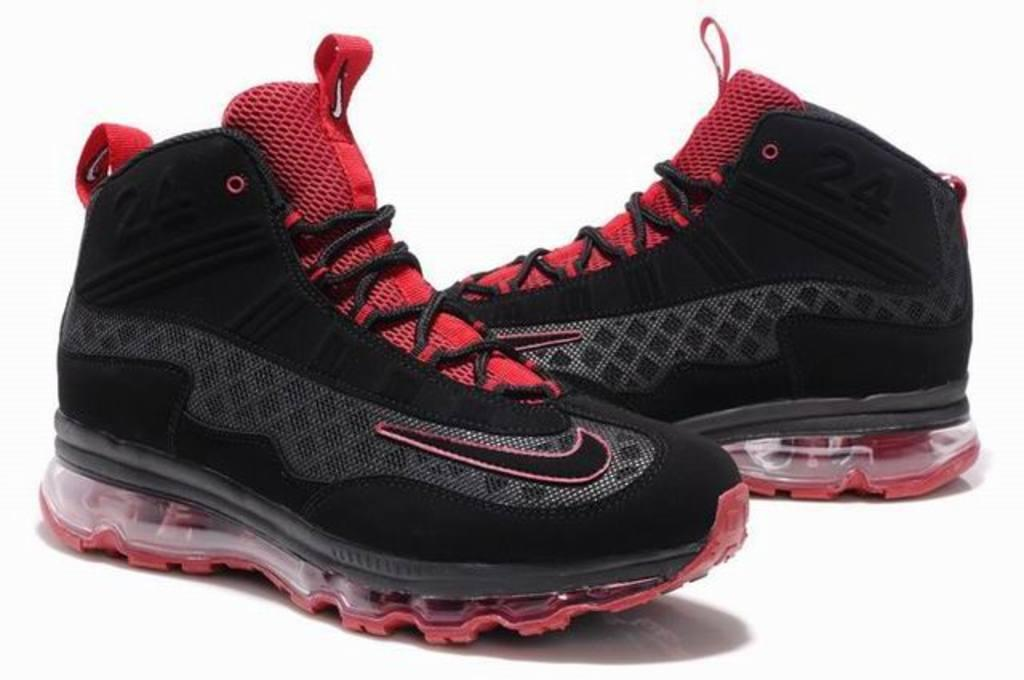What objects are present in the image? There are shoes in the image. Where are the shoes placed? The shoes are on a white platform. What color is the platform? The platform is white. What can be seen in the background of the image? The background of the image is white. What type of nerve is visible in the image? There is no nerve present in the image; it features shoes on a white platform with a white background. 